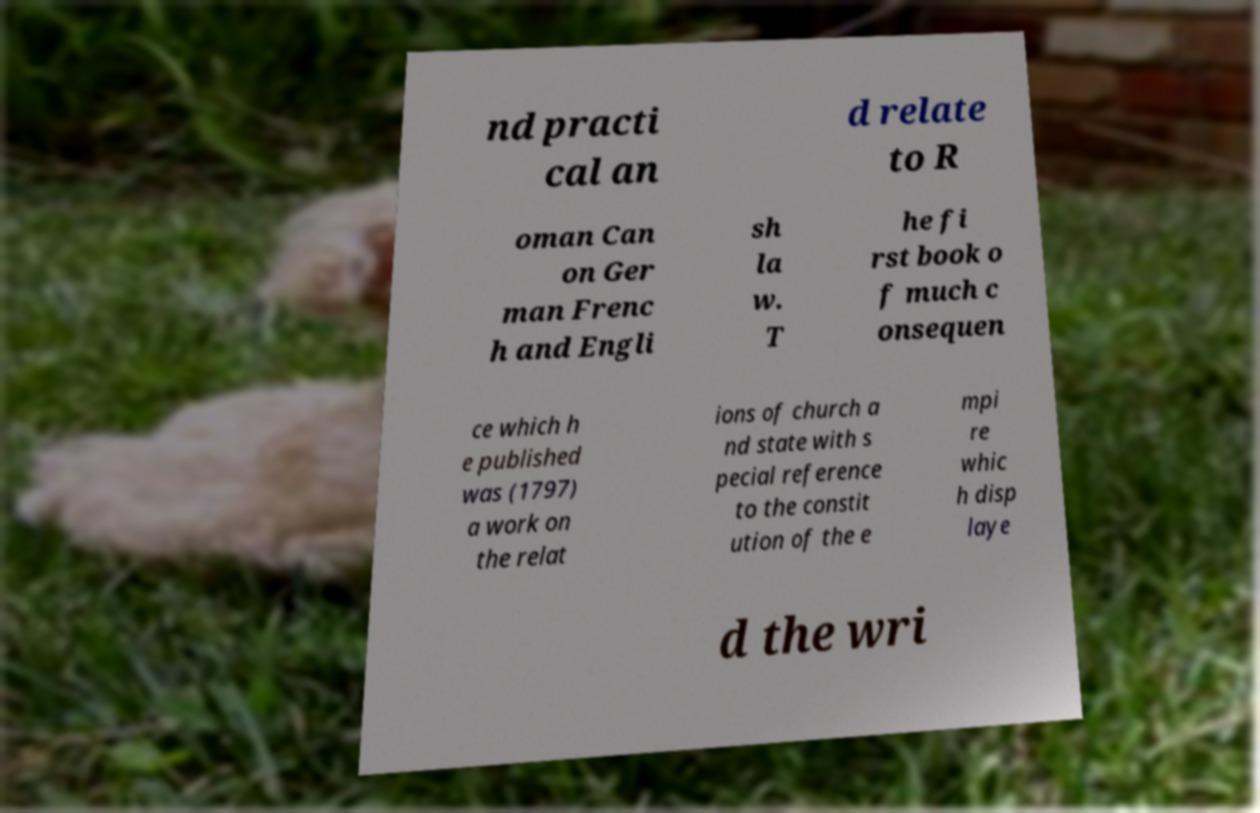Can you read and provide the text displayed in the image?This photo seems to have some interesting text. Can you extract and type it out for me? nd practi cal an d relate to R oman Can on Ger man Frenc h and Engli sh la w. T he fi rst book o f much c onsequen ce which h e published was (1797) a work on the relat ions of church a nd state with s pecial reference to the constit ution of the e mpi re whic h disp laye d the wri 